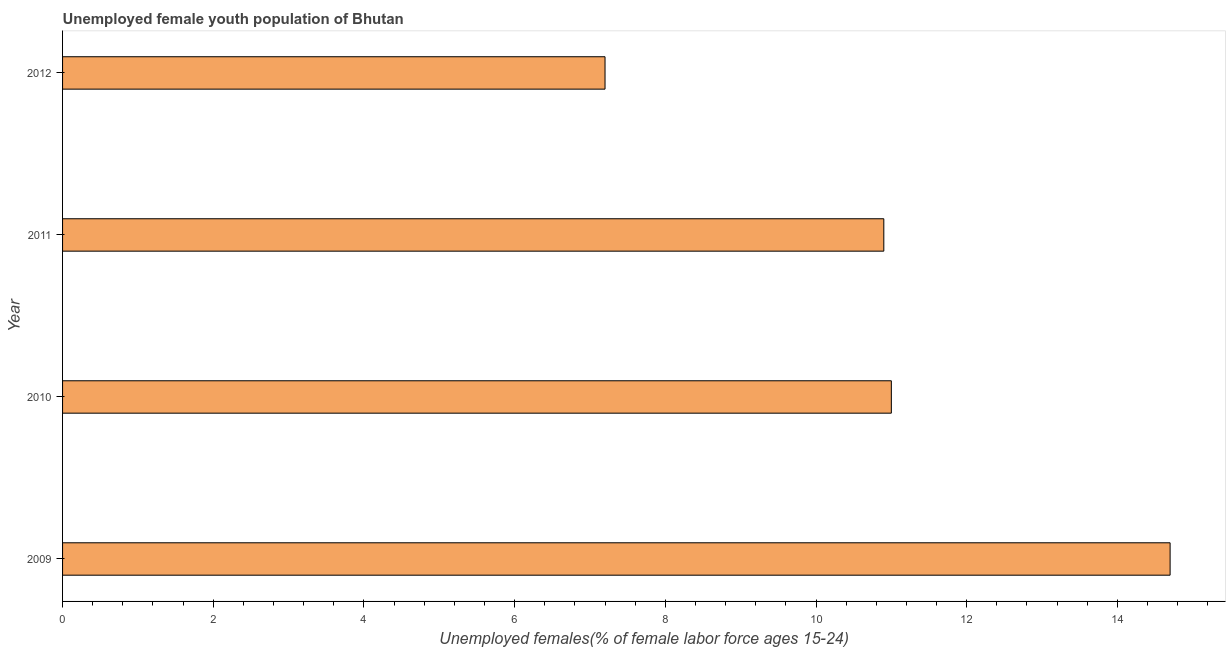Does the graph contain grids?
Provide a succinct answer. No. What is the title of the graph?
Provide a succinct answer. Unemployed female youth population of Bhutan. What is the label or title of the X-axis?
Ensure brevity in your answer.  Unemployed females(% of female labor force ages 15-24). What is the unemployed female youth in 2010?
Provide a succinct answer. 11. Across all years, what is the maximum unemployed female youth?
Your answer should be very brief. 14.7. Across all years, what is the minimum unemployed female youth?
Offer a terse response. 7.2. In which year was the unemployed female youth maximum?
Provide a succinct answer. 2009. What is the sum of the unemployed female youth?
Your response must be concise. 43.8. What is the average unemployed female youth per year?
Offer a terse response. 10.95. What is the median unemployed female youth?
Make the answer very short. 10.95. Do a majority of the years between 2009 and 2011 (inclusive) have unemployed female youth greater than 2.4 %?
Give a very brief answer. Yes. What is the ratio of the unemployed female youth in 2011 to that in 2012?
Keep it short and to the point. 1.51. Is the unemployed female youth in 2009 less than that in 2010?
Your answer should be very brief. No. Is the difference between the unemployed female youth in 2010 and 2012 greater than the difference between any two years?
Your answer should be compact. No. Is the sum of the unemployed female youth in 2009 and 2012 greater than the maximum unemployed female youth across all years?
Ensure brevity in your answer.  Yes. In how many years, is the unemployed female youth greater than the average unemployed female youth taken over all years?
Keep it short and to the point. 2. Are all the bars in the graph horizontal?
Offer a very short reply. Yes. How many years are there in the graph?
Offer a terse response. 4. What is the difference between two consecutive major ticks on the X-axis?
Keep it short and to the point. 2. What is the Unemployed females(% of female labor force ages 15-24) in 2009?
Provide a short and direct response. 14.7. What is the Unemployed females(% of female labor force ages 15-24) in 2010?
Provide a short and direct response. 11. What is the Unemployed females(% of female labor force ages 15-24) of 2011?
Your response must be concise. 10.9. What is the Unemployed females(% of female labor force ages 15-24) in 2012?
Give a very brief answer. 7.2. What is the difference between the Unemployed females(% of female labor force ages 15-24) in 2009 and 2010?
Provide a short and direct response. 3.7. What is the difference between the Unemployed females(% of female labor force ages 15-24) in 2009 and 2011?
Your answer should be compact. 3.8. What is the difference between the Unemployed females(% of female labor force ages 15-24) in 2010 and 2011?
Offer a terse response. 0.1. What is the difference between the Unemployed females(% of female labor force ages 15-24) in 2010 and 2012?
Your answer should be very brief. 3.8. What is the difference between the Unemployed females(% of female labor force ages 15-24) in 2011 and 2012?
Provide a succinct answer. 3.7. What is the ratio of the Unemployed females(% of female labor force ages 15-24) in 2009 to that in 2010?
Provide a succinct answer. 1.34. What is the ratio of the Unemployed females(% of female labor force ages 15-24) in 2009 to that in 2011?
Offer a very short reply. 1.35. What is the ratio of the Unemployed females(% of female labor force ages 15-24) in 2009 to that in 2012?
Ensure brevity in your answer.  2.04. What is the ratio of the Unemployed females(% of female labor force ages 15-24) in 2010 to that in 2012?
Give a very brief answer. 1.53. What is the ratio of the Unemployed females(% of female labor force ages 15-24) in 2011 to that in 2012?
Make the answer very short. 1.51. 